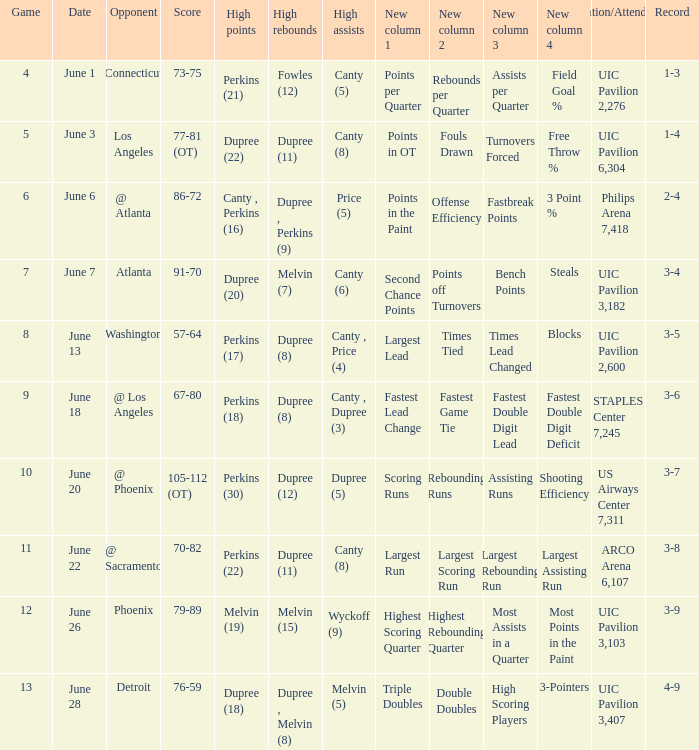Who had the most assists in the game that led to a 3-7 record? Dupree (5). 